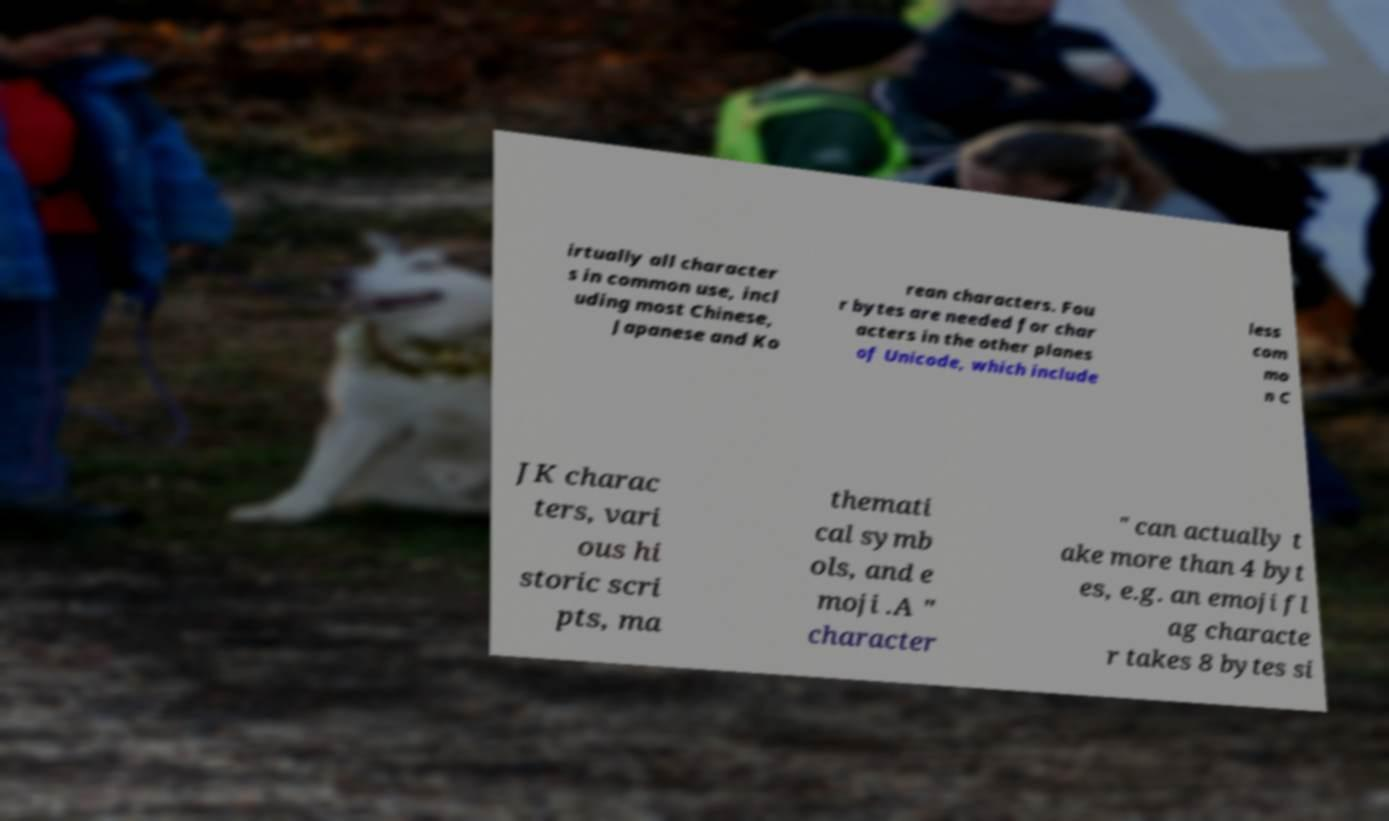Please read and relay the text visible in this image. What does it say? irtually all character s in common use, incl uding most Chinese, Japanese and Ko rean characters. Fou r bytes are needed for char acters in the other planes of Unicode, which include less com mo n C JK charac ters, vari ous hi storic scri pts, ma themati cal symb ols, and e moji .A " character " can actually t ake more than 4 byt es, e.g. an emoji fl ag characte r takes 8 bytes si 